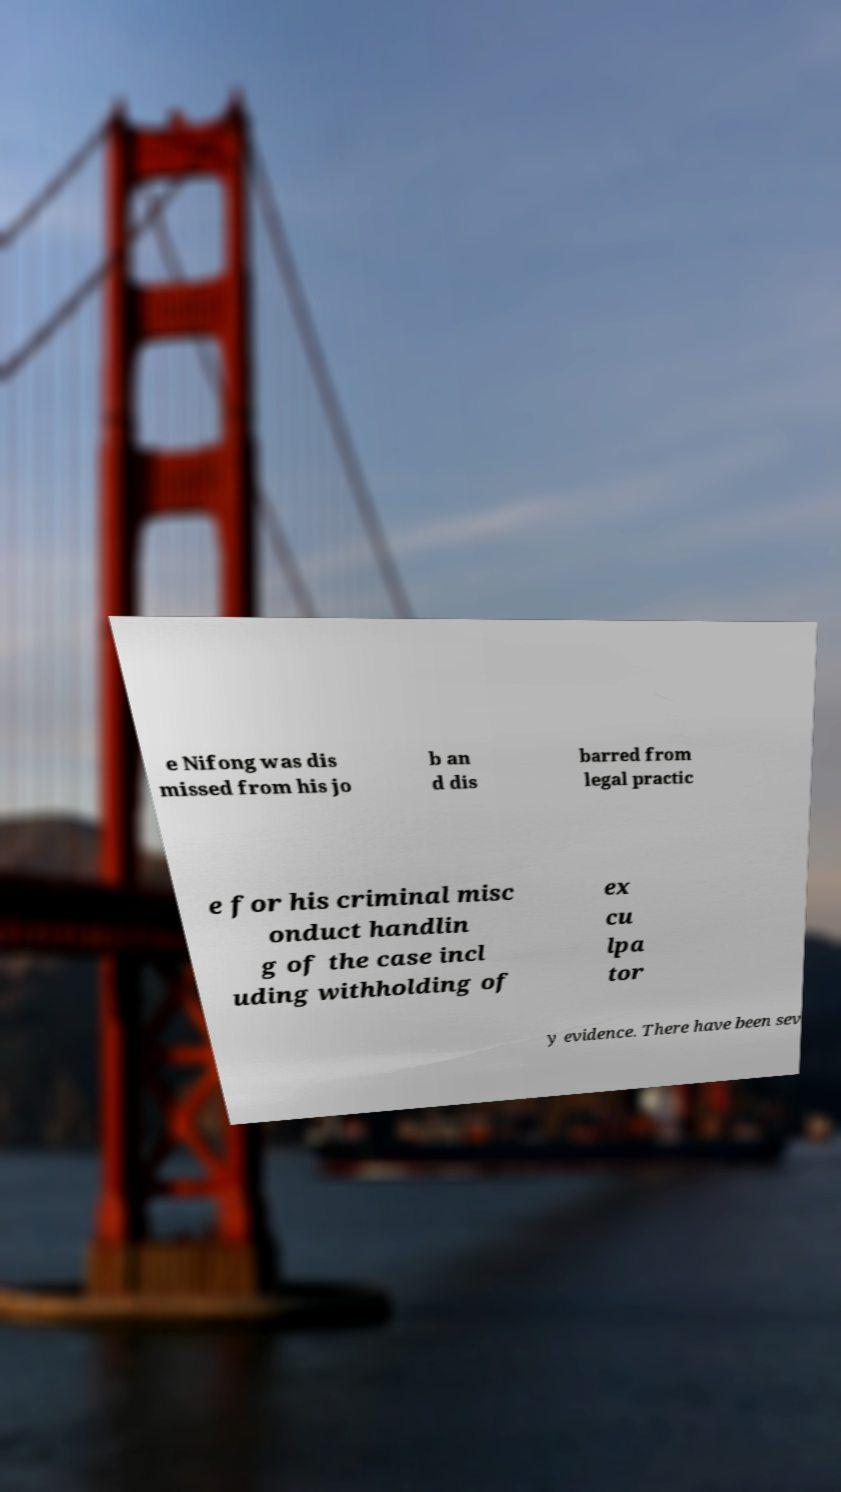Can you accurately transcribe the text from the provided image for me? e Nifong was dis missed from his jo b an d dis barred from legal practic e for his criminal misc onduct handlin g of the case incl uding withholding of ex cu lpa tor y evidence. There have been sev 